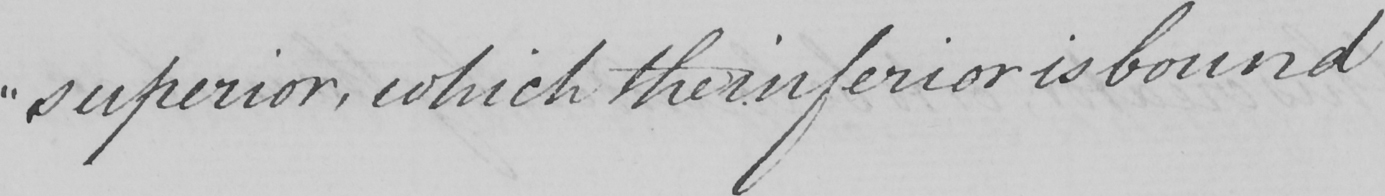Please transcribe the handwritten text in this image. " superior , which the inferior is bound 